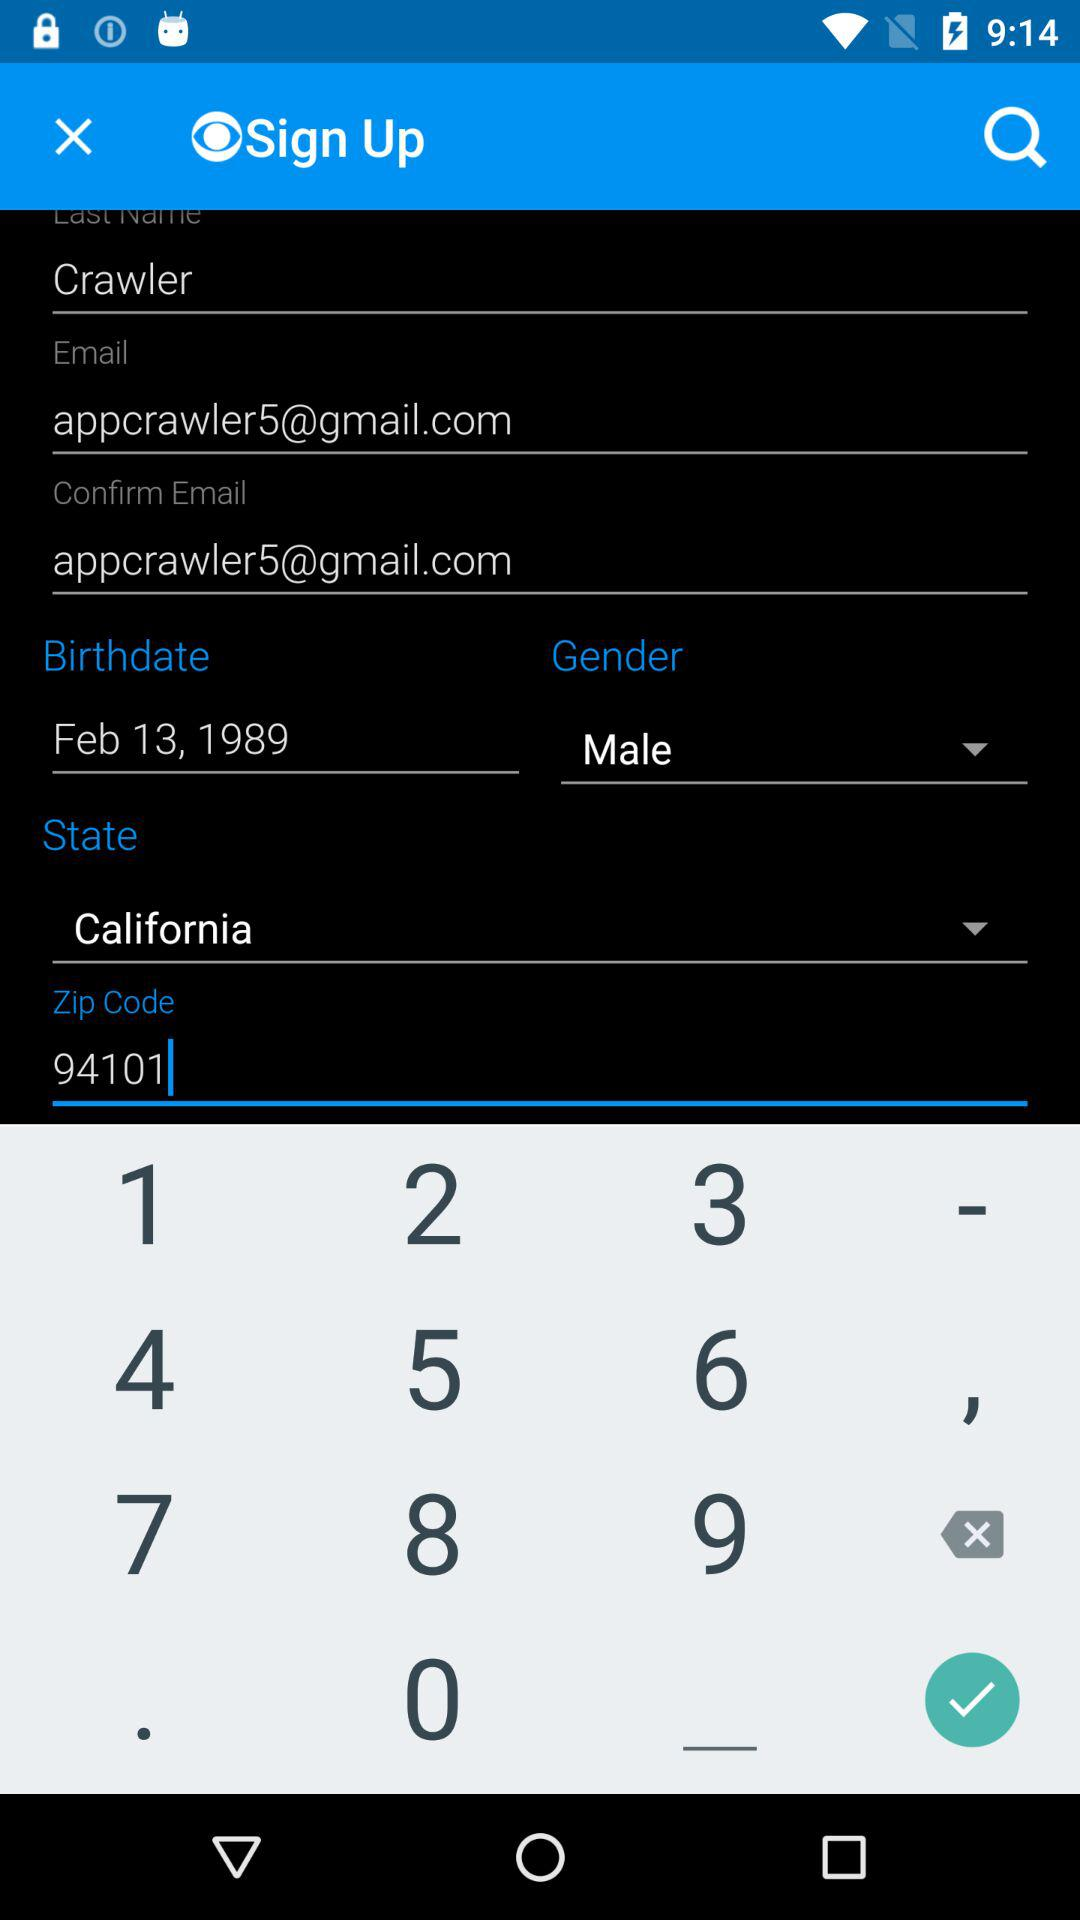How many social media options are available to sign in with?
Answer the question using a single word or phrase. 3 